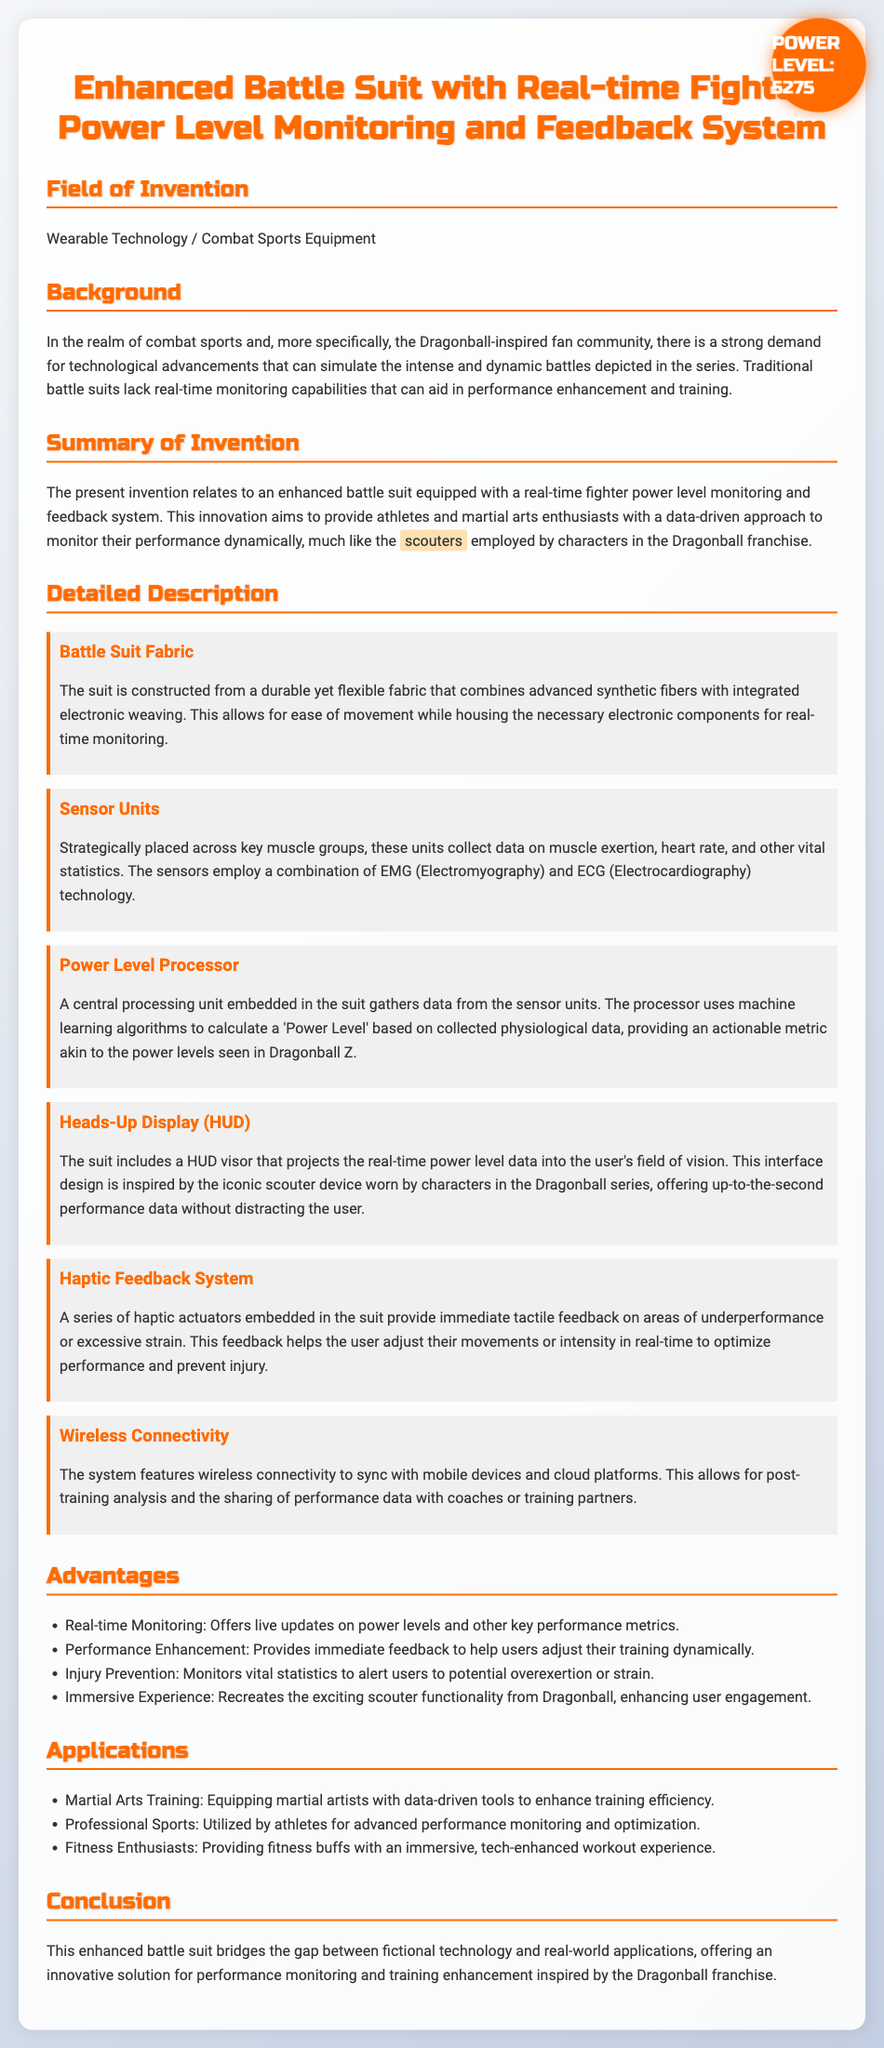What is the field of invention? The field of invention is Wearable Technology / Combat Sports Equipment.
Answer: Wearable Technology / Combat Sports Equipment What technology combines to monitor the user's physiological data? The sensors employ a combination of EMG (Electromyography) and ECG (Electrocardiography) technology.
Answer: EMG and ECG What device inspired the HUD visor in the suit? The interface design is inspired by the iconic scouter device worn by characters in the Dragonball series.
Answer: Scouter What is the purpose of the haptic feedback system? The feedback helps the user adjust their movements or intensity in real-time to optimize performance and prevent injury.
Answer: Optimize performance and prevent injury How often does the power level update in the application? The power level updates every 3 seconds.
Answer: 3 seconds What is a key advantage of the enhanced battle suit? One key advantage is real-time monitoring.
Answer: Real-time monitoring What does the power level processor use to calculate the 'Power Level'? The processor uses machine learning algorithms to calculate the 'Power Level'.
Answer: Machine learning algorithms In what context could the suit be utilized? It could be utilized in Martial Arts Training.
Answer: Martial Arts Training 